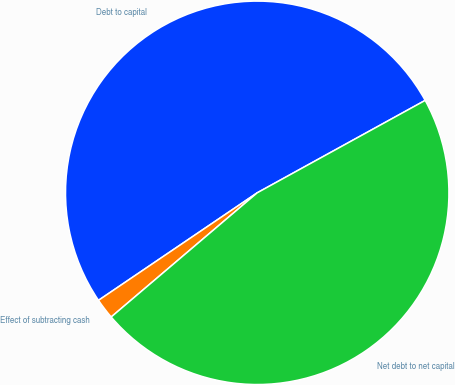Convert chart. <chart><loc_0><loc_0><loc_500><loc_500><pie_chart><fcel>Debt to capital<fcel>Effect of subtracting cash<fcel>Net debt to net capital<nl><fcel>51.47%<fcel>1.74%<fcel>46.79%<nl></chart> 